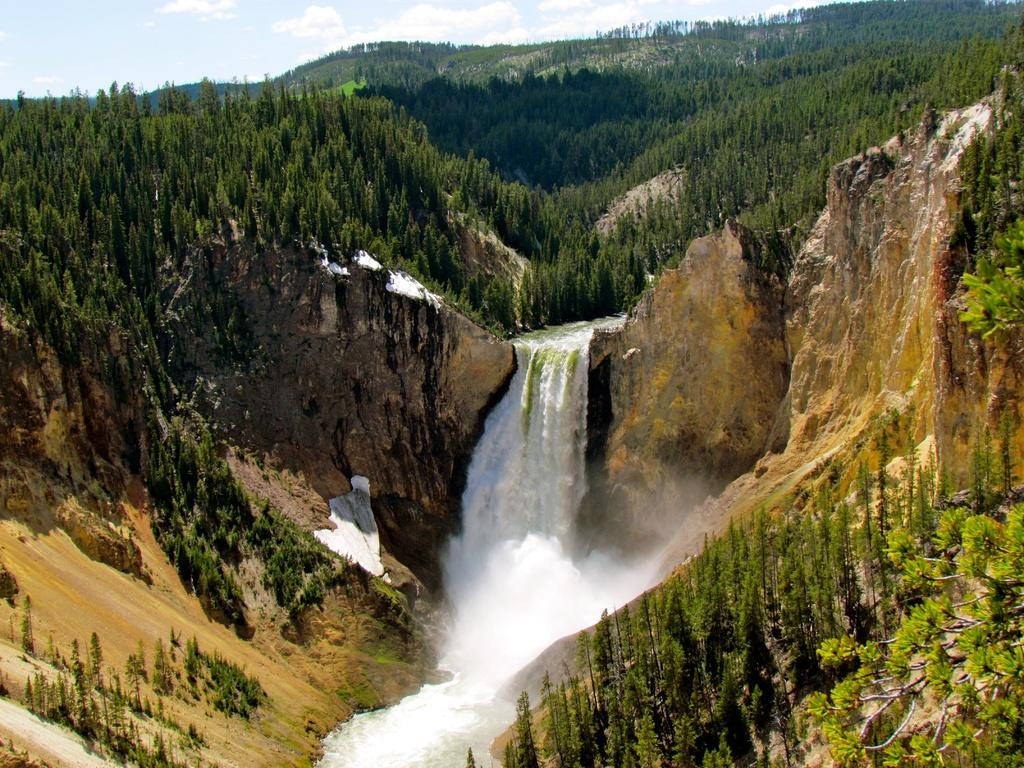What is the main feature in the center of the image? There is a waterfall in the center of the image. What can be seen on the right side of the image? There are hills and trees on the right side of the image. What is present on the left side of the image? There are hills and trees on the left side of the image. What is visible in the background of the image? There are trees, hills, and the sky in the background of the image. Can you describe the sky in the image? The sky is visible in the background of the image, and there are clouds present. How many wounds can be seen on the waterfall in the image? There are no wounds present on the waterfall in the image. Is there a battle taking place in the image? There is no indication of a battle in the image; it features a waterfall, hills, trees, and a sky with clouds. 